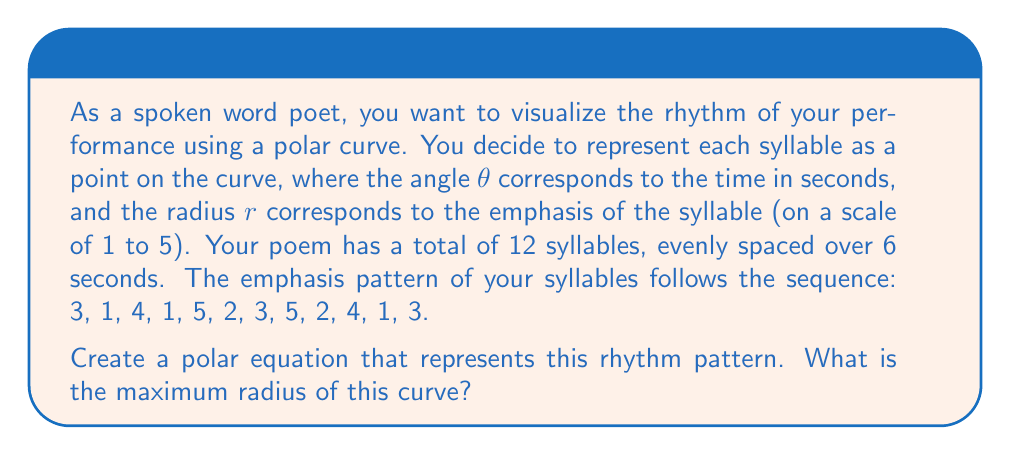What is the answer to this math problem? Let's approach this step-by-step:

1) First, we need to create a function that relates $\theta$ to $r$. 

2) We know that:
   - The poem lasts 6 seconds
   - There are 12 syllables
   - Each syllable occurs every $\frac{6}{12} = 0.5$ seconds

3) We can represent this as:
   $$\theta = 0.5n \text{ (in radians)}, \text{ where } n = 0, 1, 2, ..., 11$$

4) Now, we need to create a function that gives us the correct radius for each angle. We can use a piecewise function for this:

   $$r(\theta) = \begin{cases}
   3, & 0 \leq \theta < \frac{\pi}{6} \\
   1, & \frac{\pi}{6} \leq \theta < \frac{\pi}{3} \\
   4, & \frac{\pi}{3} \leq \theta < \frac{\pi}{2} \\
   1, & \frac{\pi}{2} \leq \theta < \frac{2\pi}{3} \\
   5, & \frac{2\pi}{3} \leq \theta < \frac{5\pi}{6} \\
   2, & \frac{5\pi}{6} \leq \theta < \pi \\
   3, & \pi \leq \theta < \frac{7\pi}{6} \\
   5, & \frac{7\pi}{6} \leq \theta < \frac{4\pi}{3} \\
   2, & \frac{4\pi}{3} \leq \theta < \frac{3\pi}{2} \\
   4, & \frac{3\pi}{2} \leq \theta < \frac{5\pi}{3} \\
   1, & \frac{5\pi}{3} \leq \theta < \frac{11\pi}{6} \\
   3, & \frac{11\pi}{6} \leq \theta < 2\pi
   \end{cases}$$

5) To find the maximum radius, we simply need to find the largest value in our emphasis sequence, which is 5.
Answer: The polar equation is the piecewise function $r(\theta)$ as defined in the explanation. The maximum radius of this curve is 5. 